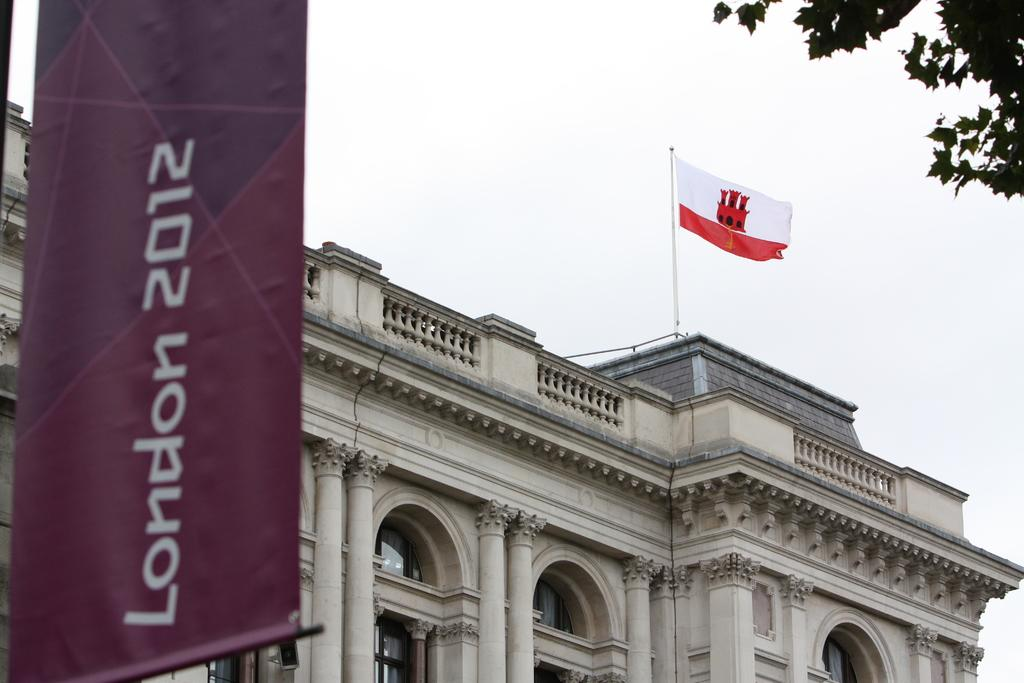What type of structure is present in the image? There is a building in the image. What can be seen flying near the building? There is a flag in the image. What message or information is displayed in the image? There is a banner with text in the image. What type of natural element is present in the image? There is a tree in the image. What is visible in the background of the image? The sky is visible in the background of the image. What type of knowledge is being imparted by the tree in the image? The tree is not imparting any knowledge in the image; it is a natural element. What tool is being used to construct the building in the image? There is no tool visible in the image, and the construction process is not depicted. 